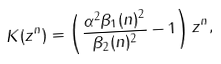Convert formula to latex. <formula><loc_0><loc_0><loc_500><loc_500>K ( z ^ { n } ) & = \left ( \frac { \alpha ^ { 2 } \beta _ { 1 } ( n ) ^ { 2 } } { \beta _ { 2 } ( n ) ^ { 2 } } - 1 \right ) z ^ { n } ,</formula> 